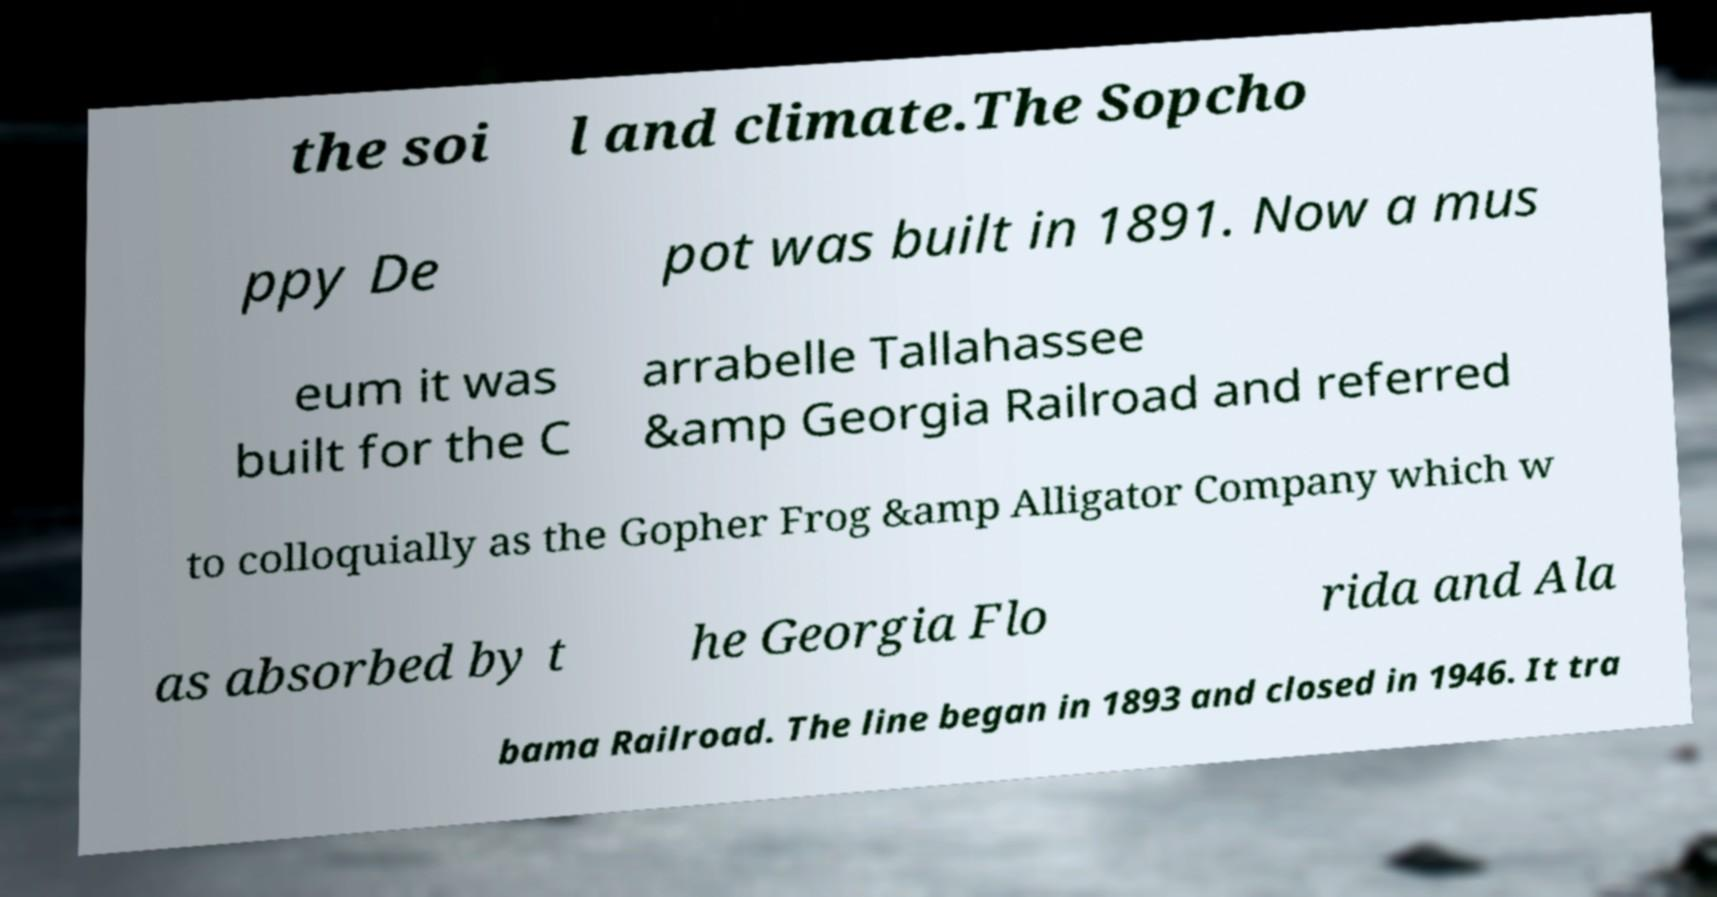I need the written content from this picture converted into text. Can you do that? the soi l and climate.The Sopcho ppy De pot was built in 1891. Now a mus eum it was built for the C arrabelle Tallahassee &amp Georgia Railroad and referred to colloquially as the Gopher Frog &amp Alligator Company which w as absorbed by t he Georgia Flo rida and Ala bama Railroad. The line began in 1893 and closed in 1946. It tra 